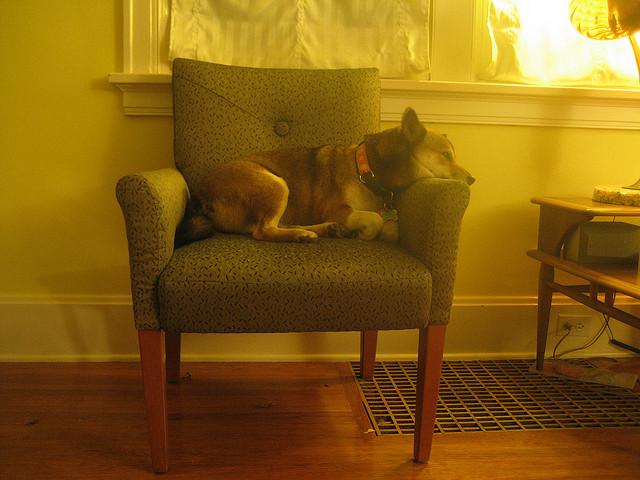What time of day could it be?
Give a very brief answer. Night. How many electrical outlets are visible?
Keep it brief. 1. Who is petting the dog?
Be succinct. No one. What is the grate on the floor?
Answer briefly. Vent. 